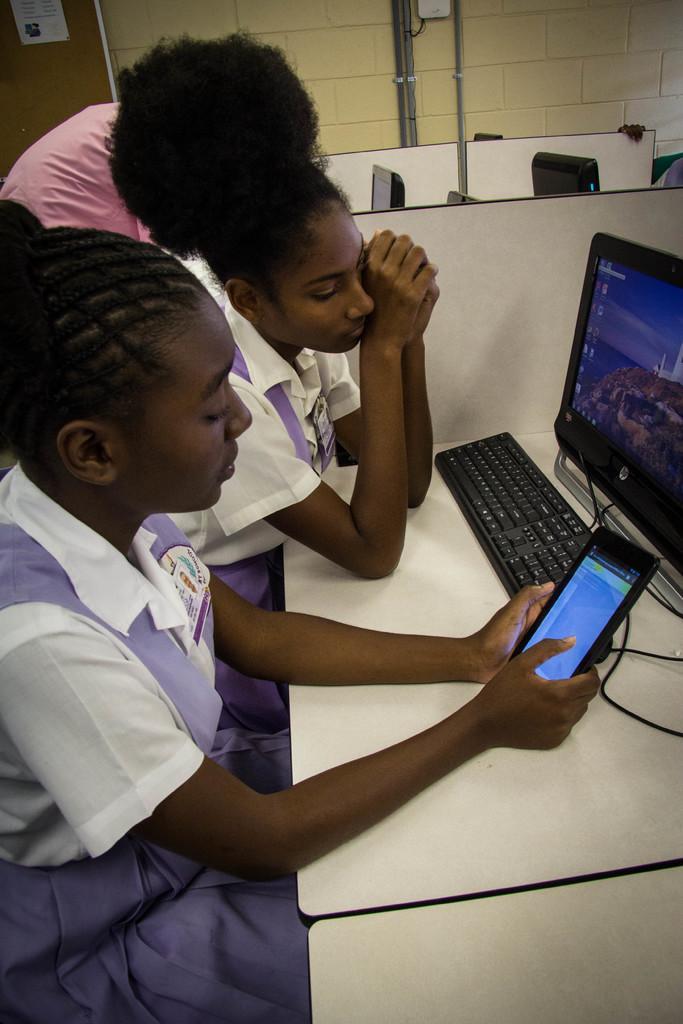Could you give a brief overview of what you see in this image? In the foreground of the picture there are two girls, desktop, cables, desks, mobile phone. In the center of the picture there are desks, desktop, person and other objects. In the background there are pipes, wall, door and poster. 